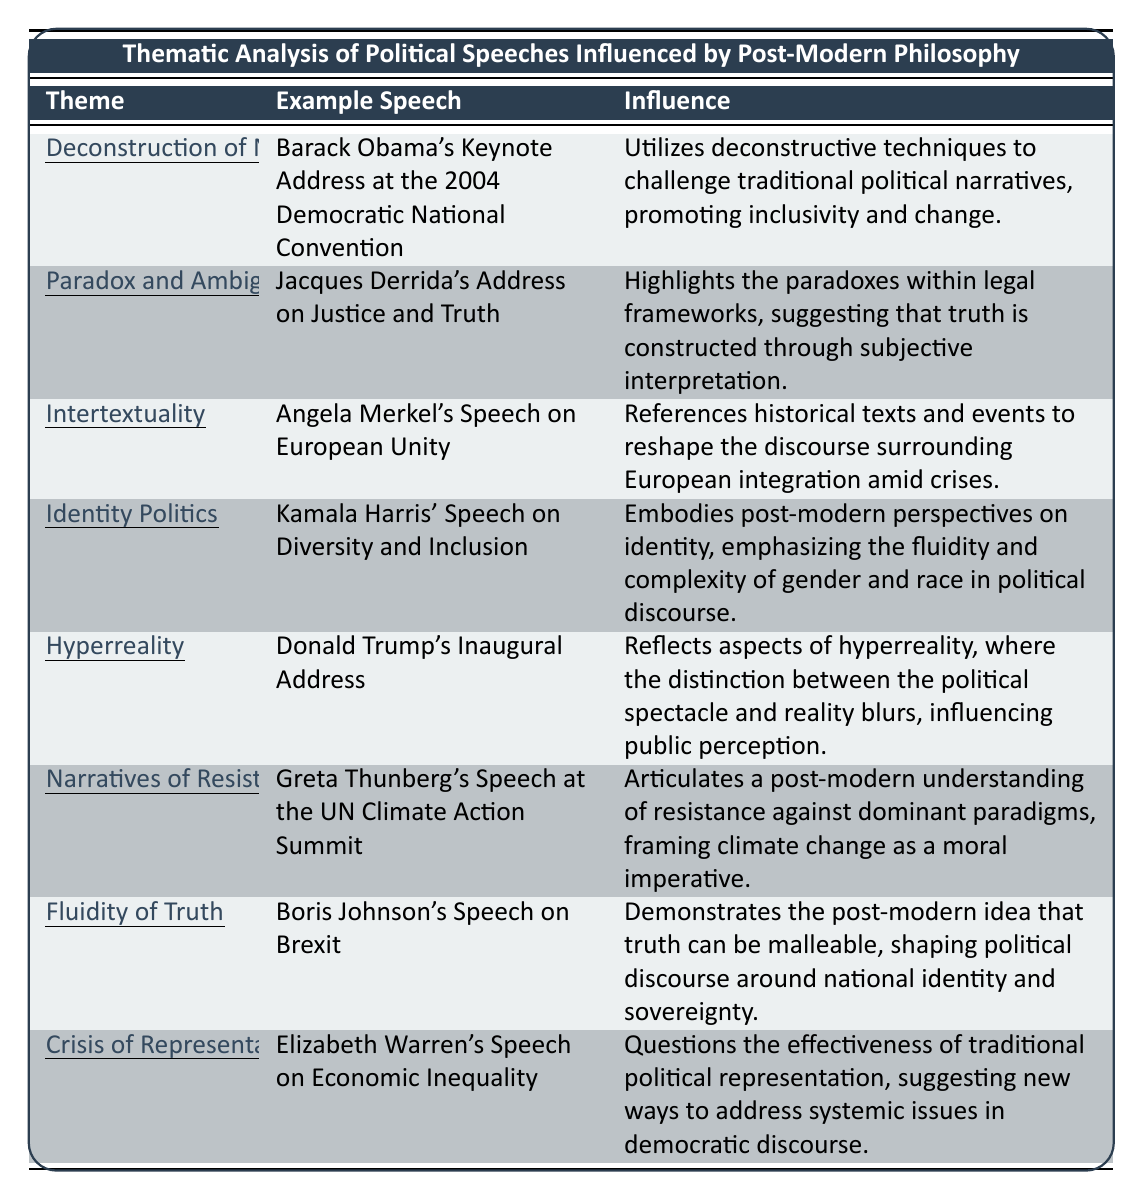What is the theme associated with Barack Obama's speech? The theme associated with Barack Obama's speech is listed in the first row of the table, which states "Deconstruction of Narratives."
Answer: Deconstruction of Narratives Which speech highlights "Paradox and Ambiguity"? The speech that highlights "Paradox and Ambiguity" is mentioned in the second row of the table, which is "Jacques Derrida's Address on Justice and Truth."
Answer: Jacques Derrida's Address on Justice and Truth Does Kamala Harris' speech focus on Identity Politics? The table shows that Kamala Harris' speech is explicitly linked to the theme of "Identity Politics," confirming the statement is true.
Answer: Yes How many themes are related to speeches that emphasize post-modern concepts? There are 8 themes listed in the table, all of which relate to various speeches influenced by post-modern philosophy.
Answer: 8 Which speech addresses the theme of "Hyperreality"? The speech addressing the theme of "Hyperreality" is found in row five, which is "Donald Trump's Inaugural Address."
Answer: Donald Trump's Inaugural Address Identify the influence associated with Elizabeth Warren's speech. The influence associated with Elizabeth Warren's speech is described in the last row, stating it questions traditional political representation and addresses systemic issues.
Answer: Questions the effectiveness of traditional political representation Among the speeches listed, which one reflects the concept of "Fluidity of Truth"? Referring to the seventh row which mentions that "Boris Johnson's Speech on Brexit" illustrates the post-modern notion of malleable truth.
Answer: Boris Johnson's Speech on Brexit What is the average number of words in the influence descriptions for all speeches? There are 8 influence descriptions in total, and summing the approximate word counts gives 84, so the average is 84/8 = 10.5.
Answer: 10.5 Find the speech that emphasizes "Narratives of Resistance". This theme is highlighted in the sixth row of the table, which mentions "Greta Thunberg's Speech at the UN Climate Action Summit."
Answer: Greta Thunberg's Speech at the UN Climate Action Summit What is the influence detailed for Angela Merkel's speech? According to the table, the influence for Angela Merkel's speech on "Intertextuality" involves referencing historical texts to reshape discourse about European integration.
Answer: References historical texts and events to reshape the discourse surrounding European integration amid crises 